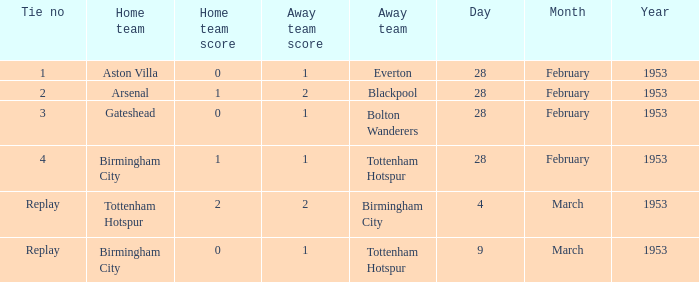What score is associated with a tie of 1? 0–1. 